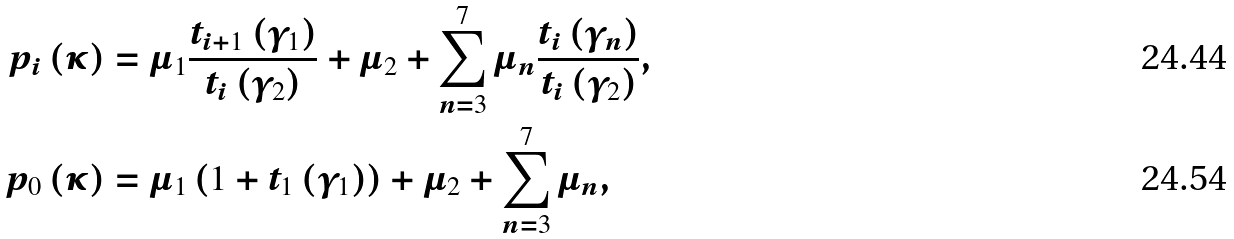<formula> <loc_0><loc_0><loc_500><loc_500>p _ { i } \left ( \kappa \right ) & = \mu _ { 1 } \frac { t _ { i + 1 } \left ( \gamma _ { 1 } \right ) } { t _ { i } \left ( \gamma _ { 2 } \right ) } + \mu _ { 2 } + \sum _ { n = 3 } ^ { 7 } \mu _ { n } \frac { t _ { i } \left ( \gamma _ { n } \right ) } { t _ { i } \left ( \gamma _ { 2 } \right ) } , \\ p _ { 0 } \left ( \kappa \right ) & = \mu _ { 1 } \left ( 1 + t _ { 1 } \left ( \gamma _ { 1 } \right ) \right ) + \mu _ { 2 } + \sum _ { n = 3 } ^ { 7 } \mu _ { n } ,</formula> 